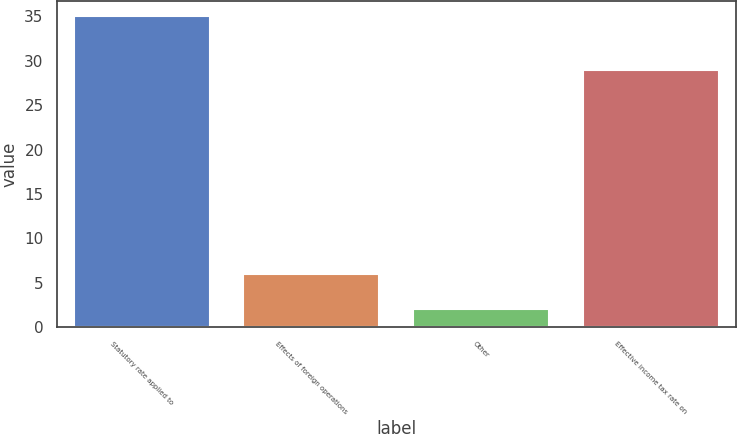Convert chart. <chart><loc_0><loc_0><loc_500><loc_500><bar_chart><fcel>Statutory rate applied to<fcel>Effects of foreign operations<fcel>Other<fcel>Effective income tax rate on<nl><fcel>35<fcel>6<fcel>2<fcel>29<nl></chart> 